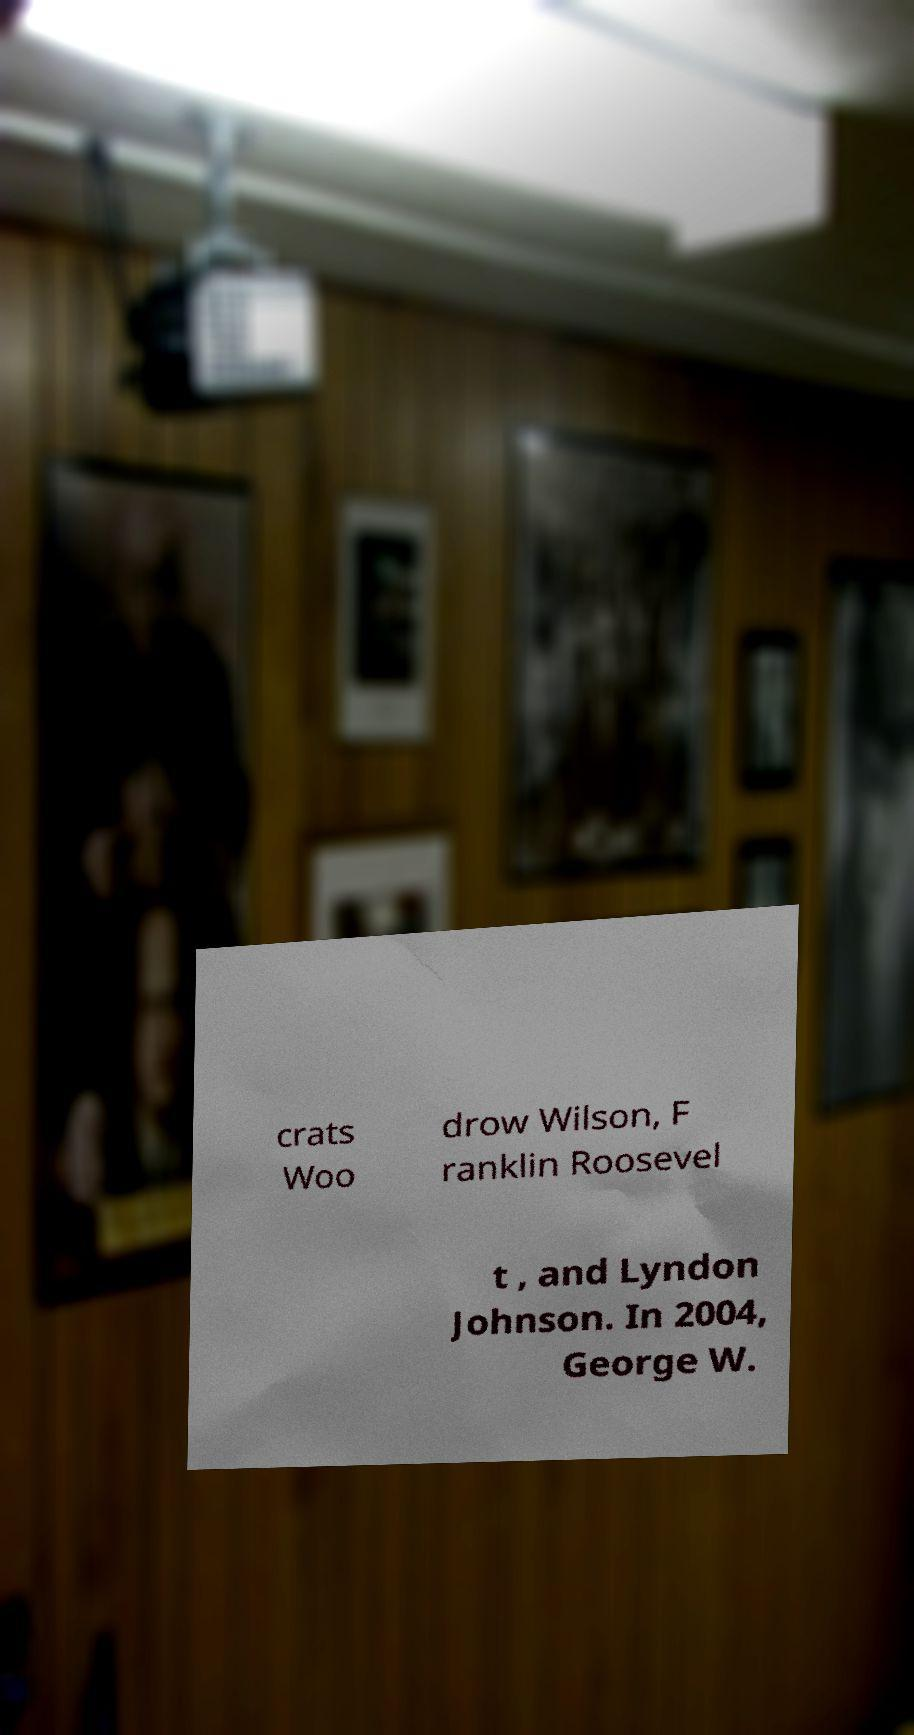Could you assist in decoding the text presented in this image and type it out clearly? crats Woo drow Wilson, F ranklin Roosevel t , and Lyndon Johnson. In 2004, George W. 